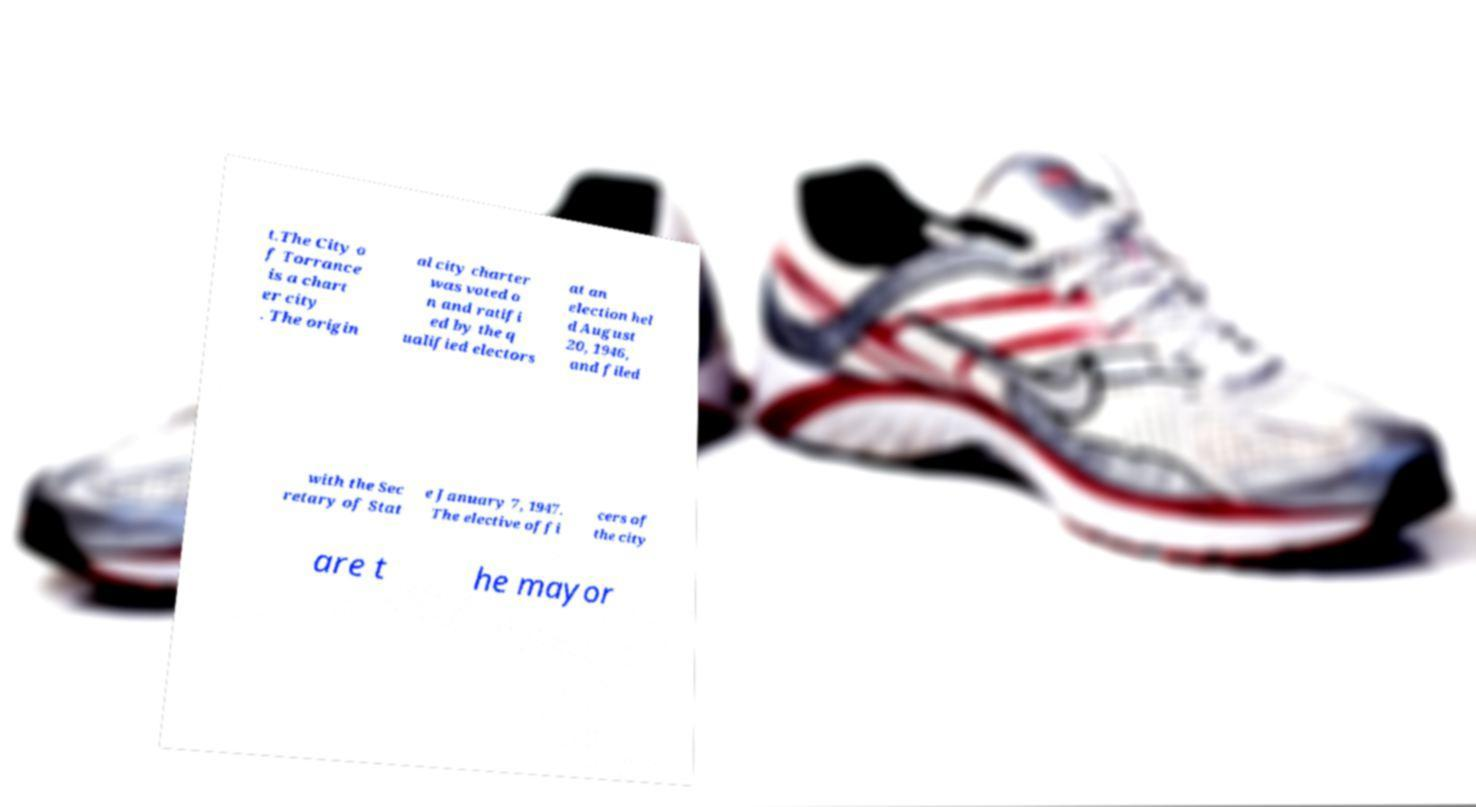Can you read and provide the text displayed in the image?This photo seems to have some interesting text. Can you extract and type it out for me? t.The City o f Torrance is a chart er city . The origin al city charter was voted o n and ratifi ed by the q ualified electors at an election hel d August 20, 1946, and filed with the Sec retary of Stat e January 7, 1947. The elective offi cers of the city are t he mayor 